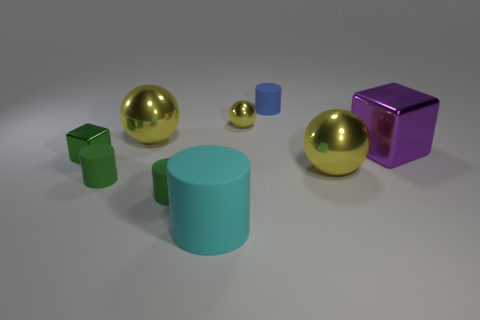The sphere that is behind the large yellow shiny ball that is behind the big purple metal cube is made of what material?
Your response must be concise. Metal. How many rubber objects are either tiny blue cylinders or large yellow objects?
Offer a very short reply. 1. The other big rubber object that is the same shape as the blue matte object is what color?
Give a very brief answer. Cyan. What number of big balls are the same color as the small sphere?
Your response must be concise. 2. There is a yellow sphere in front of the purple block; are there any cyan cylinders that are left of it?
Make the answer very short. Yes. What number of things are both behind the small green shiny object and to the left of the cyan object?
Make the answer very short. 1. How many green cylinders are made of the same material as the blue thing?
Offer a terse response. 2. How big is the metal sphere that is in front of the sphere that is left of the cyan rubber cylinder?
Offer a very short reply. Large. Is there a big gray rubber object that has the same shape as the green metallic object?
Provide a short and direct response. No. There is a sphere in front of the large purple metallic thing; is it the same size as the shiny block to the right of the big cylinder?
Offer a very short reply. Yes. 